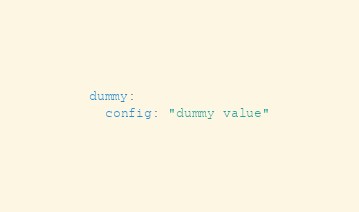Convert code to text. <code><loc_0><loc_0><loc_500><loc_500><_YAML_>dummy:
  config: "dummy value"</code> 